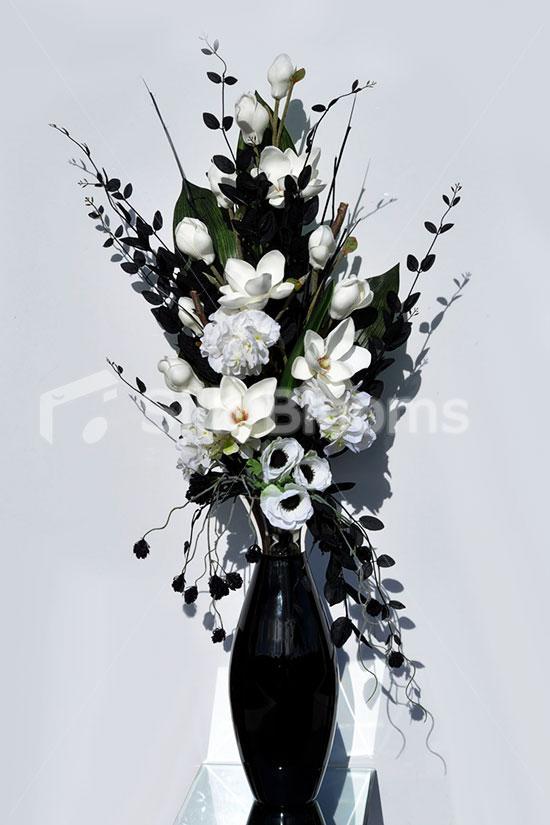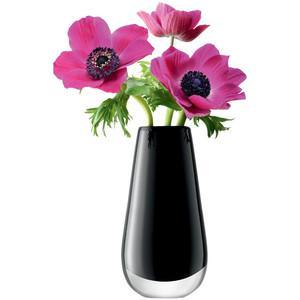The first image is the image on the left, the second image is the image on the right. Analyze the images presented: Is the assertion "The right image contains white flowers in a black vase." valid? Answer yes or no. No. 